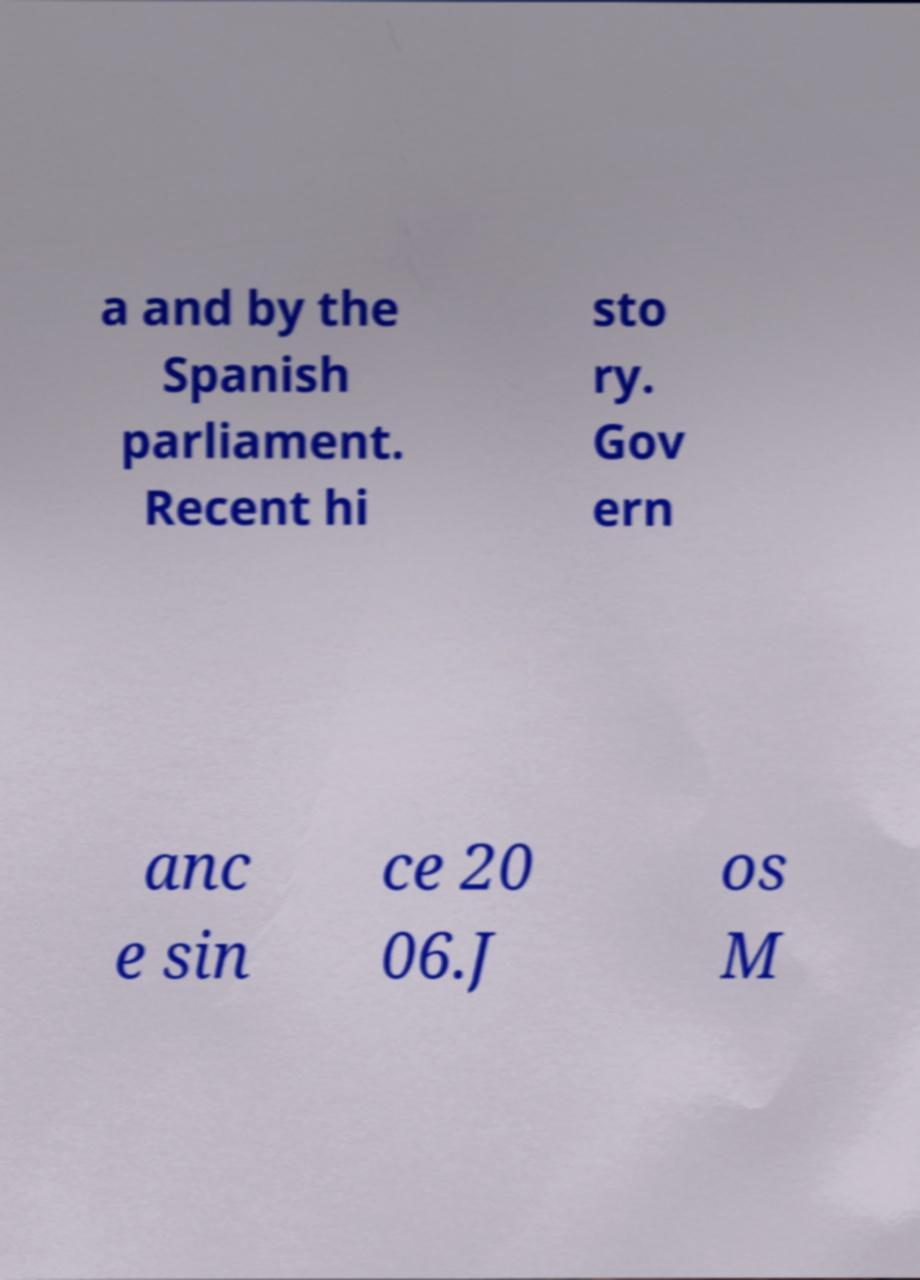Please identify and transcribe the text found in this image. a and by the Spanish parliament. Recent hi sto ry. Gov ern anc e sin ce 20 06.J os M 